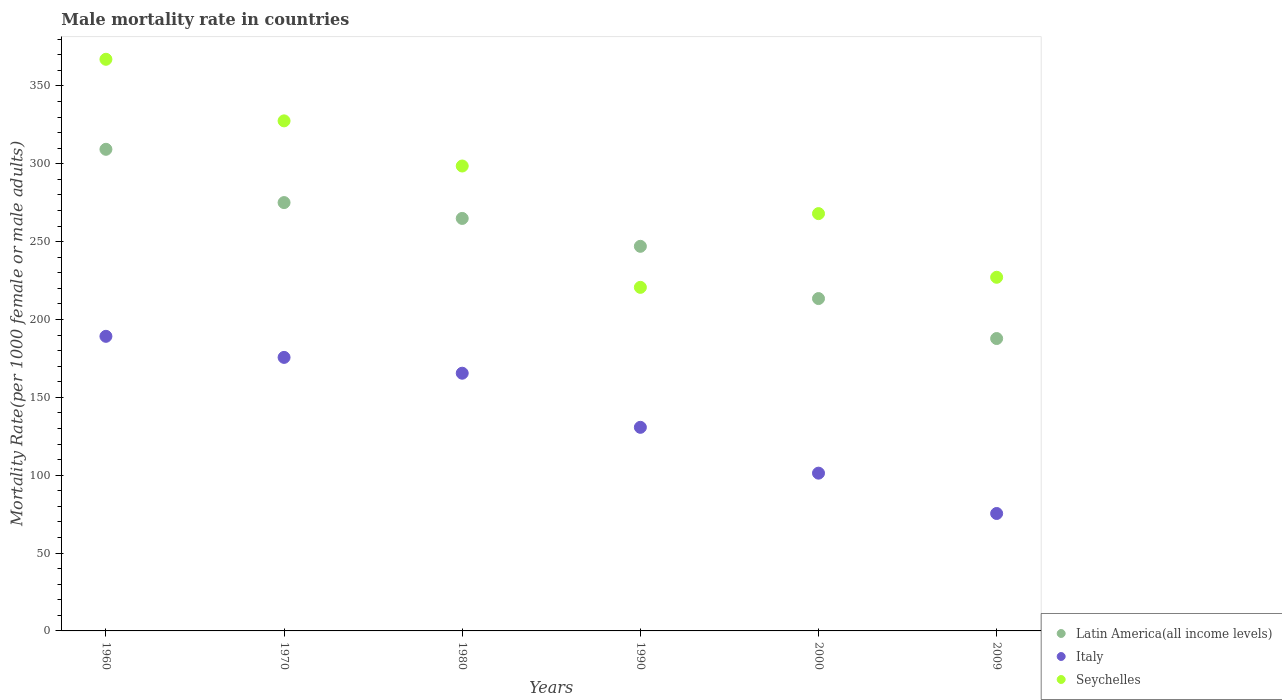How many different coloured dotlines are there?
Provide a succinct answer. 3. What is the male mortality rate in Italy in 1980?
Offer a very short reply. 165.5. Across all years, what is the maximum male mortality rate in Latin America(all income levels)?
Your response must be concise. 309.3. Across all years, what is the minimum male mortality rate in Latin America(all income levels)?
Ensure brevity in your answer.  187.78. What is the total male mortality rate in Seychelles in the graph?
Keep it short and to the point. 1709.01. What is the difference between the male mortality rate in Latin America(all income levels) in 1980 and that in 1990?
Offer a terse response. 17.91. What is the difference between the male mortality rate in Seychelles in 1960 and the male mortality rate in Latin America(all income levels) in 2000?
Your answer should be very brief. 153.67. What is the average male mortality rate in Latin America(all income levels) per year?
Ensure brevity in your answer.  249.58. In the year 1960, what is the difference between the male mortality rate in Latin America(all income levels) and male mortality rate in Italy?
Your answer should be compact. 120.1. What is the ratio of the male mortality rate in Latin America(all income levels) in 1960 to that in 2000?
Provide a succinct answer. 1.45. Is the difference between the male mortality rate in Latin America(all income levels) in 1980 and 2000 greater than the difference between the male mortality rate in Italy in 1980 and 2000?
Your answer should be compact. No. What is the difference between the highest and the second highest male mortality rate in Italy?
Offer a very short reply. 13.53. What is the difference between the highest and the lowest male mortality rate in Seychelles?
Provide a short and direct response. 146.47. Is the male mortality rate in Italy strictly less than the male mortality rate in Latin America(all income levels) over the years?
Keep it short and to the point. Yes. How many dotlines are there?
Make the answer very short. 3. How many years are there in the graph?
Your answer should be very brief. 6. Are the values on the major ticks of Y-axis written in scientific E-notation?
Make the answer very short. No. Does the graph contain grids?
Offer a terse response. No. Where does the legend appear in the graph?
Offer a terse response. Bottom right. How many legend labels are there?
Ensure brevity in your answer.  3. How are the legend labels stacked?
Offer a terse response. Vertical. What is the title of the graph?
Provide a short and direct response. Male mortality rate in countries. What is the label or title of the Y-axis?
Your response must be concise. Mortality Rate(per 1000 female or male adults). What is the Mortality Rate(per 1000 female or male adults) in Latin America(all income levels) in 1960?
Offer a very short reply. 309.3. What is the Mortality Rate(per 1000 female or male adults) of Italy in 1960?
Offer a very short reply. 189.2. What is the Mortality Rate(per 1000 female or male adults) of Seychelles in 1960?
Your response must be concise. 367.11. What is the Mortality Rate(per 1000 female or male adults) in Latin America(all income levels) in 1970?
Offer a terse response. 275.08. What is the Mortality Rate(per 1000 female or male adults) of Italy in 1970?
Provide a short and direct response. 175.66. What is the Mortality Rate(per 1000 female or male adults) of Seychelles in 1970?
Offer a terse response. 327.56. What is the Mortality Rate(per 1000 female or male adults) in Latin America(all income levels) in 1980?
Your response must be concise. 264.91. What is the Mortality Rate(per 1000 female or male adults) of Italy in 1980?
Offer a very short reply. 165.5. What is the Mortality Rate(per 1000 female or male adults) of Seychelles in 1980?
Give a very brief answer. 298.57. What is the Mortality Rate(per 1000 female or male adults) of Latin America(all income levels) in 1990?
Offer a terse response. 247. What is the Mortality Rate(per 1000 female or male adults) in Italy in 1990?
Keep it short and to the point. 130.75. What is the Mortality Rate(per 1000 female or male adults) in Seychelles in 1990?
Give a very brief answer. 220.65. What is the Mortality Rate(per 1000 female or male adults) in Latin America(all income levels) in 2000?
Make the answer very short. 213.44. What is the Mortality Rate(per 1000 female or male adults) in Italy in 2000?
Give a very brief answer. 101.32. What is the Mortality Rate(per 1000 female or male adults) of Seychelles in 2000?
Offer a very short reply. 268. What is the Mortality Rate(per 1000 female or male adults) in Latin America(all income levels) in 2009?
Provide a succinct answer. 187.78. What is the Mortality Rate(per 1000 female or male adults) of Italy in 2009?
Ensure brevity in your answer.  75.42. What is the Mortality Rate(per 1000 female or male adults) in Seychelles in 2009?
Your answer should be very brief. 227.12. Across all years, what is the maximum Mortality Rate(per 1000 female or male adults) in Latin America(all income levels)?
Make the answer very short. 309.3. Across all years, what is the maximum Mortality Rate(per 1000 female or male adults) of Italy?
Your answer should be compact. 189.2. Across all years, what is the maximum Mortality Rate(per 1000 female or male adults) of Seychelles?
Provide a succinct answer. 367.11. Across all years, what is the minimum Mortality Rate(per 1000 female or male adults) of Latin America(all income levels)?
Provide a succinct answer. 187.78. Across all years, what is the minimum Mortality Rate(per 1000 female or male adults) of Italy?
Offer a terse response. 75.42. Across all years, what is the minimum Mortality Rate(per 1000 female or male adults) of Seychelles?
Your answer should be very brief. 220.65. What is the total Mortality Rate(per 1000 female or male adults) in Latin America(all income levels) in the graph?
Provide a short and direct response. 1497.51. What is the total Mortality Rate(per 1000 female or male adults) in Italy in the graph?
Keep it short and to the point. 837.85. What is the total Mortality Rate(per 1000 female or male adults) in Seychelles in the graph?
Give a very brief answer. 1709.01. What is the difference between the Mortality Rate(per 1000 female or male adults) of Latin America(all income levels) in 1960 and that in 1970?
Keep it short and to the point. 34.22. What is the difference between the Mortality Rate(per 1000 female or male adults) in Italy in 1960 and that in 1970?
Provide a short and direct response. 13.53. What is the difference between the Mortality Rate(per 1000 female or male adults) of Seychelles in 1960 and that in 1970?
Make the answer very short. 39.55. What is the difference between the Mortality Rate(per 1000 female or male adults) in Latin America(all income levels) in 1960 and that in 1980?
Keep it short and to the point. 44.39. What is the difference between the Mortality Rate(per 1000 female or male adults) of Italy in 1960 and that in 1980?
Keep it short and to the point. 23.7. What is the difference between the Mortality Rate(per 1000 female or male adults) of Seychelles in 1960 and that in 1980?
Provide a short and direct response. 68.54. What is the difference between the Mortality Rate(per 1000 female or male adults) in Latin America(all income levels) in 1960 and that in 1990?
Your answer should be very brief. 62.3. What is the difference between the Mortality Rate(per 1000 female or male adults) of Italy in 1960 and that in 1990?
Keep it short and to the point. 58.44. What is the difference between the Mortality Rate(per 1000 female or male adults) of Seychelles in 1960 and that in 1990?
Give a very brief answer. 146.47. What is the difference between the Mortality Rate(per 1000 female or male adults) of Latin America(all income levels) in 1960 and that in 2000?
Ensure brevity in your answer.  95.86. What is the difference between the Mortality Rate(per 1000 female or male adults) of Italy in 1960 and that in 2000?
Ensure brevity in your answer.  87.88. What is the difference between the Mortality Rate(per 1000 female or male adults) in Seychelles in 1960 and that in 2000?
Offer a terse response. 99.11. What is the difference between the Mortality Rate(per 1000 female or male adults) of Latin America(all income levels) in 1960 and that in 2009?
Ensure brevity in your answer.  121.53. What is the difference between the Mortality Rate(per 1000 female or male adults) in Italy in 1960 and that in 2009?
Your response must be concise. 113.78. What is the difference between the Mortality Rate(per 1000 female or male adults) in Seychelles in 1960 and that in 2009?
Ensure brevity in your answer.  139.99. What is the difference between the Mortality Rate(per 1000 female or male adults) of Latin America(all income levels) in 1970 and that in 1980?
Make the answer very short. 10.17. What is the difference between the Mortality Rate(per 1000 female or male adults) in Italy in 1970 and that in 1980?
Your answer should be very brief. 10.16. What is the difference between the Mortality Rate(per 1000 female or male adults) in Seychelles in 1970 and that in 1980?
Your response must be concise. 28.99. What is the difference between the Mortality Rate(per 1000 female or male adults) in Latin America(all income levels) in 1970 and that in 1990?
Keep it short and to the point. 28.09. What is the difference between the Mortality Rate(per 1000 female or male adults) in Italy in 1970 and that in 1990?
Your response must be concise. 44.91. What is the difference between the Mortality Rate(per 1000 female or male adults) of Seychelles in 1970 and that in 1990?
Your answer should be very brief. 106.92. What is the difference between the Mortality Rate(per 1000 female or male adults) of Latin America(all income levels) in 1970 and that in 2000?
Offer a terse response. 61.64. What is the difference between the Mortality Rate(per 1000 female or male adults) in Italy in 1970 and that in 2000?
Provide a short and direct response. 74.34. What is the difference between the Mortality Rate(per 1000 female or male adults) of Seychelles in 1970 and that in 2000?
Keep it short and to the point. 59.56. What is the difference between the Mortality Rate(per 1000 female or male adults) in Latin America(all income levels) in 1970 and that in 2009?
Offer a very short reply. 87.31. What is the difference between the Mortality Rate(per 1000 female or male adults) of Italy in 1970 and that in 2009?
Your answer should be very brief. 100.24. What is the difference between the Mortality Rate(per 1000 female or male adults) of Seychelles in 1970 and that in 2009?
Your answer should be compact. 100.44. What is the difference between the Mortality Rate(per 1000 female or male adults) of Latin America(all income levels) in 1980 and that in 1990?
Make the answer very short. 17.91. What is the difference between the Mortality Rate(per 1000 female or male adults) of Italy in 1980 and that in 1990?
Keep it short and to the point. 34.74. What is the difference between the Mortality Rate(per 1000 female or male adults) in Seychelles in 1980 and that in 1990?
Your response must be concise. 77.93. What is the difference between the Mortality Rate(per 1000 female or male adults) of Latin America(all income levels) in 1980 and that in 2000?
Your response must be concise. 51.47. What is the difference between the Mortality Rate(per 1000 female or male adults) of Italy in 1980 and that in 2000?
Make the answer very short. 64.18. What is the difference between the Mortality Rate(per 1000 female or male adults) in Seychelles in 1980 and that in 2000?
Provide a short and direct response. 30.57. What is the difference between the Mortality Rate(per 1000 female or male adults) of Latin America(all income levels) in 1980 and that in 2009?
Give a very brief answer. 77.13. What is the difference between the Mortality Rate(per 1000 female or male adults) in Italy in 1980 and that in 2009?
Your answer should be compact. 90.08. What is the difference between the Mortality Rate(per 1000 female or male adults) in Seychelles in 1980 and that in 2009?
Your answer should be very brief. 71.46. What is the difference between the Mortality Rate(per 1000 female or male adults) in Latin America(all income levels) in 1990 and that in 2000?
Ensure brevity in your answer.  33.55. What is the difference between the Mortality Rate(per 1000 female or male adults) in Italy in 1990 and that in 2000?
Provide a short and direct response. 29.43. What is the difference between the Mortality Rate(per 1000 female or male adults) of Seychelles in 1990 and that in 2000?
Offer a very short reply. -47.35. What is the difference between the Mortality Rate(per 1000 female or male adults) in Latin America(all income levels) in 1990 and that in 2009?
Give a very brief answer. 59.22. What is the difference between the Mortality Rate(per 1000 female or male adults) of Italy in 1990 and that in 2009?
Your answer should be compact. 55.34. What is the difference between the Mortality Rate(per 1000 female or male adults) in Seychelles in 1990 and that in 2009?
Your response must be concise. -6.47. What is the difference between the Mortality Rate(per 1000 female or male adults) in Latin America(all income levels) in 2000 and that in 2009?
Ensure brevity in your answer.  25.67. What is the difference between the Mortality Rate(per 1000 female or male adults) in Italy in 2000 and that in 2009?
Give a very brief answer. 25.9. What is the difference between the Mortality Rate(per 1000 female or male adults) of Seychelles in 2000 and that in 2009?
Offer a terse response. 40.88. What is the difference between the Mortality Rate(per 1000 female or male adults) of Latin America(all income levels) in 1960 and the Mortality Rate(per 1000 female or male adults) of Italy in 1970?
Ensure brevity in your answer.  133.64. What is the difference between the Mortality Rate(per 1000 female or male adults) in Latin America(all income levels) in 1960 and the Mortality Rate(per 1000 female or male adults) in Seychelles in 1970?
Ensure brevity in your answer.  -18.26. What is the difference between the Mortality Rate(per 1000 female or male adults) of Italy in 1960 and the Mortality Rate(per 1000 female or male adults) of Seychelles in 1970?
Your answer should be very brief. -138.36. What is the difference between the Mortality Rate(per 1000 female or male adults) in Latin America(all income levels) in 1960 and the Mortality Rate(per 1000 female or male adults) in Italy in 1980?
Your answer should be compact. 143.8. What is the difference between the Mortality Rate(per 1000 female or male adults) of Latin America(all income levels) in 1960 and the Mortality Rate(per 1000 female or male adults) of Seychelles in 1980?
Your answer should be very brief. 10.73. What is the difference between the Mortality Rate(per 1000 female or male adults) of Italy in 1960 and the Mortality Rate(per 1000 female or male adults) of Seychelles in 1980?
Offer a very short reply. -109.38. What is the difference between the Mortality Rate(per 1000 female or male adults) in Latin America(all income levels) in 1960 and the Mortality Rate(per 1000 female or male adults) in Italy in 1990?
Provide a succinct answer. 178.55. What is the difference between the Mortality Rate(per 1000 female or male adults) in Latin America(all income levels) in 1960 and the Mortality Rate(per 1000 female or male adults) in Seychelles in 1990?
Offer a very short reply. 88.65. What is the difference between the Mortality Rate(per 1000 female or male adults) of Italy in 1960 and the Mortality Rate(per 1000 female or male adults) of Seychelles in 1990?
Make the answer very short. -31.45. What is the difference between the Mortality Rate(per 1000 female or male adults) in Latin America(all income levels) in 1960 and the Mortality Rate(per 1000 female or male adults) in Italy in 2000?
Ensure brevity in your answer.  207.98. What is the difference between the Mortality Rate(per 1000 female or male adults) in Latin America(all income levels) in 1960 and the Mortality Rate(per 1000 female or male adults) in Seychelles in 2000?
Provide a succinct answer. 41.3. What is the difference between the Mortality Rate(per 1000 female or male adults) of Italy in 1960 and the Mortality Rate(per 1000 female or male adults) of Seychelles in 2000?
Provide a succinct answer. -78.8. What is the difference between the Mortality Rate(per 1000 female or male adults) of Latin America(all income levels) in 1960 and the Mortality Rate(per 1000 female or male adults) of Italy in 2009?
Provide a succinct answer. 233.88. What is the difference between the Mortality Rate(per 1000 female or male adults) of Latin America(all income levels) in 1960 and the Mortality Rate(per 1000 female or male adults) of Seychelles in 2009?
Make the answer very short. 82.18. What is the difference between the Mortality Rate(per 1000 female or male adults) of Italy in 1960 and the Mortality Rate(per 1000 female or male adults) of Seychelles in 2009?
Ensure brevity in your answer.  -37.92. What is the difference between the Mortality Rate(per 1000 female or male adults) in Latin America(all income levels) in 1970 and the Mortality Rate(per 1000 female or male adults) in Italy in 1980?
Ensure brevity in your answer.  109.58. What is the difference between the Mortality Rate(per 1000 female or male adults) of Latin America(all income levels) in 1970 and the Mortality Rate(per 1000 female or male adults) of Seychelles in 1980?
Offer a terse response. -23.49. What is the difference between the Mortality Rate(per 1000 female or male adults) of Italy in 1970 and the Mortality Rate(per 1000 female or male adults) of Seychelles in 1980?
Offer a terse response. -122.91. What is the difference between the Mortality Rate(per 1000 female or male adults) in Latin America(all income levels) in 1970 and the Mortality Rate(per 1000 female or male adults) in Italy in 1990?
Give a very brief answer. 144.33. What is the difference between the Mortality Rate(per 1000 female or male adults) of Latin America(all income levels) in 1970 and the Mortality Rate(per 1000 female or male adults) of Seychelles in 1990?
Give a very brief answer. 54.44. What is the difference between the Mortality Rate(per 1000 female or male adults) in Italy in 1970 and the Mortality Rate(per 1000 female or male adults) in Seychelles in 1990?
Provide a succinct answer. -44.98. What is the difference between the Mortality Rate(per 1000 female or male adults) in Latin America(all income levels) in 1970 and the Mortality Rate(per 1000 female or male adults) in Italy in 2000?
Make the answer very short. 173.76. What is the difference between the Mortality Rate(per 1000 female or male adults) in Latin America(all income levels) in 1970 and the Mortality Rate(per 1000 female or male adults) in Seychelles in 2000?
Give a very brief answer. 7.08. What is the difference between the Mortality Rate(per 1000 female or male adults) of Italy in 1970 and the Mortality Rate(per 1000 female or male adults) of Seychelles in 2000?
Keep it short and to the point. -92.34. What is the difference between the Mortality Rate(per 1000 female or male adults) of Latin America(all income levels) in 1970 and the Mortality Rate(per 1000 female or male adults) of Italy in 2009?
Provide a succinct answer. 199.66. What is the difference between the Mortality Rate(per 1000 female or male adults) in Latin America(all income levels) in 1970 and the Mortality Rate(per 1000 female or male adults) in Seychelles in 2009?
Offer a very short reply. 47.97. What is the difference between the Mortality Rate(per 1000 female or male adults) in Italy in 1970 and the Mortality Rate(per 1000 female or male adults) in Seychelles in 2009?
Offer a very short reply. -51.45. What is the difference between the Mortality Rate(per 1000 female or male adults) of Latin America(all income levels) in 1980 and the Mortality Rate(per 1000 female or male adults) of Italy in 1990?
Make the answer very short. 134.16. What is the difference between the Mortality Rate(per 1000 female or male adults) in Latin America(all income levels) in 1980 and the Mortality Rate(per 1000 female or male adults) in Seychelles in 1990?
Give a very brief answer. 44.26. What is the difference between the Mortality Rate(per 1000 female or male adults) of Italy in 1980 and the Mortality Rate(per 1000 female or male adults) of Seychelles in 1990?
Keep it short and to the point. -55.15. What is the difference between the Mortality Rate(per 1000 female or male adults) in Latin America(all income levels) in 1980 and the Mortality Rate(per 1000 female or male adults) in Italy in 2000?
Your response must be concise. 163.59. What is the difference between the Mortality Rate(per 1000 female or male adults) of Latin America(all income levels) in 1980 and the Mortality Rate(per 1000 female or male adults) of Seychelles in 2000?
Provide a succinct answer. -3.09. What is the difference between the Mortality Rate(per 1000 female or male adults) in Italy in 1980 and the Mortality Rate(per 1000 female or male adults) in Seychelles in 2000?
Offer a terse response. -102.5. What is the difference between the Mortality Rate(per 1000 female or male adults) in Latin America(all income levels) in 1980 and the Mortality Rate(per 1000 female or male adults) in Italy in 2009?
Your answer should be very brief. 189.49. What is the difference between the Mortality Rate(per 1000 female or male adults) in Latin America(all income levels) in 1980 and the Mortality Rate(per 1000 female or male adults) in Seychelles in 2009?
Provide a short and direct response. 37.79. What is the difference between the Mortality Rate(per 1000 female or male adults) in Italy in 1980 and the Mortality Rate(per 1000 female or male adults) in Seychelles in 2009?
Offer a very short reply. -61.62. What is the difference between the Mortality Rate(per 1000 female or male adults) in Latin America(all income levels) in 1990 and the Mortality Rate(per 1000 female or male adults) in Italy in 2000?
Offer a very short reply. 145.68. What is the difference between the Mortality Rate(per 1000 female or male adults) of Latin America(all income levels) in 1990 and the Mortality Rate(per 1000 female or male adults) of Seychelles in 2000?
Ensure brevity in your answer.  -21. What is the difference between the Mortality Rate(per 1000 female or male adults) of Italy in 1990 and the Mortality Rate(per 1000 female or male adults) of Seychelles in 2000?
Your response must be concise. -137.25. What is the difference between the Mortality Rate(per 1000 female or male adults) of Latin America(all income levels) in 1990 and the Mortality Rate(per 1000 female or male adults) of Italy in 2009?
Keep it short and to the point. 171.58. What is the difference between the Mortality Rate(per 1000 female or male adults) in Latin America(all income levels) in 1990 and the Mortality Rate(per 1000 female or male adults) in Seychelles in 2009?
Offer a terse response. 19.88. What is the difference between the Mortality Rate(per 1000 female or male adults) of Italy in 1990 and the Mortality Rate(per 1000 female or male adults) of Seychelles in 2009?
Your answer should be very brief. -96.36. What is the difference between the Mortality Rate(per 1000 female or male adults) of Latin America(all income levels) in 2000 and the Mortality Rate(per 1000 female or male adults) of Italy in 2009?
Offer a very short reply. 138.02. What is the difference between the Mortality Rate(per 1000 female or male adults) of Latin America(all income levels) in 2000 and the Mortality Rate(per 1000 female or male adults) of Seychelles in 2009?
Your response must be concise. -13.67. What is the difference between the Mortality Rate(per 1000 female or male adults) of Italy in 2000 and the Mortality Rate(per 1000 female or male adults) of Seychelles in 2009?
Your response must be concise. -125.8. What is the average Mortality Rate(per 1000 female or male adults) of Latin America(all income levels) per year?
Provide a succinct answer. 249.58. What is the average Mortality Rate(per 1000 female or male adults) in Italy per year?
Offer a terse response. 139.64. What is the average Mortality Rate(per 1000 female or male adults) in Seychelles per year?
Provide a short and direct response. 284.84. In the year 1960, what is the difference between the Mortality Rate(per 1000 female or male adults) in Latin America(all income levels) and Mortality Rate(per 1000 female or male adults) in Italy?
Make the answer very short. 120.1. In the year 1960, what is the difference between the Mortality Rate(per 1000 female or male adults) of Latin America(all income levels) and Mortality Rate(per 1000 female or male adults) of Seychelles?
Your answer should be compact. -57.81. In the year 1960, what is the difference between the Mortality Rate(per 1000 female or male adults) in Italy and Mortality Rate(per 1000 female or male adults) in Seychelles?
Ensure brevity in your answer.  -177.91. In the year 1970, what is the difference between the Mortality Rate(per 1000 female or male adults) in Latin America(all income levels) and Mortality Rate(per 1000 female or male adults) in Italy?
Give a very brief answer. 99.42. In the year 1970, what is the difference between the Mortality Rate(per 1000 female or male adults) of Latin America(all income levels) and Mortality Rate(per 1000 female or male adults) of Seychelles?
Provide a succinct answer. -52.48. In the year 1970, what is the difference between the Mortality Rate(per 1000 female or male adults) in Italy and Mortality Rate(per 1000 female or male adults) in Seychelles?
Provide a succinct answer. -151.9. In the year 1980, what is the difference between the Mortality Rate(per 1000 female or male adults) in Latin America(all income levels) and Mortality Rate(per 1000 female or male adults) in Italy?
Your response must be concise. 99.41. In the year 1980, what is the difference between the Mortality Rate(per 1000 female or male adults) of Latin America(all income levels) and Mortality Rate(per 1000 female or male adults) of Seychelles?
Make the answer very short. -33.67. In the year 1980, what is the difference between the Mortality Rate(per 1000 female or male adults) in Italy and Mortality Rate(per 1000 female or male adults) in Seychelles?
Make the answer very short. -133.08. In the year 1990, what is the difference between the Mortality Rate(per 1000 female or male adults) of Latin America(all income levels) and Mortality Rate(per 1000 female or male adults) of Italy?
Ensure brevity in your answer.  116.24. In the year 1990, what is the difference between the Mortality Rate(per 1000 female or male adults) in Latin America(all income levels) and Mortality Rate(per 1000 female or male adults) in Seychelles?
Keep it short and to the point. 26.35. In the year 1990, what is the difference between the Mortality Rate(per 1000 female or male adults) in Italy and Mortality Rate(per 1000 female or male adults) in Seychelles?
Your response must be concise. -89.89. In the year 2000, what is the difference between the Mortality Rate(per 1000 female or male adults) of Latin America(all income levels) and Mortality Rate(per 1000 female or male adults) of Italy?
Give a very brief answer. 112.12. In the year 2000, what is the difference between the Mortality Rate(per 1000 female or male adults) of Latin America(all income levels) and Mortality Rate(per 1000 female or male adults) of Seychelles?
Your response must be concise. -54.56. In the year 2000, what is the difference between the Mortality Rate(per 1000 female or male adults) in Italy and Mortality Rate(per 1000 female or male adults) in Seychelles?
Your answer should be compact. -166.68. In the year 2009, what is the difference between the Mortality Rate(per 1000 female or male adults) of Latin America(all income levels) and Mortality Rate(per 1000 female or male adults) of Italy?
Provide a succinct answer. 112.36. In the year 2009, what is the difference between the Mortality Rate(per 1000 female or male adults) of Latin America(all income levels) and Mortality Rate(per 1000 female or male adults) of Seychelles?
Offer a very short reply. -39.34. In the year 2009, what is the difference between the Mortality Rate(per 1000 female or male adults) of Italy and Mortality Rate(per 1000 female or male adults) of Seychelles?
Your answer should be very brief. -151.7. What is the ratio of the Mortality Rate(per 1000 female or male adults) of Latin America(all income levels) in 1960 to that in 1970?
Offer a very short reply. 1.12. What is the ratio of the Mortality Rate(per 1000 female or male adults) of Italy in 1960 to that in 1970?
Your response must be concise. 1.08. What is the ratio of the Mortality Rate(per 1000 female or male adults) in Seychelles in 1960 to that in 1970?
Your answer should be very brief. 1.12. What is the ratio of the Mortality Rate(per 1000 female or male adults) of Latin America(all income levels) in 1960 to that in 1980?
Your answer should be compact. 1.17. What is the ratio of the Mortality Rate(per 1000 female or male adults) of Italy in 1960 to that in 1980?
Keep it short and to the point. 1.14. What is the ratio of the Mortality Rate(per 1000 female or male adults) in Seychelles in 1960 to that in 1980?
Provide a short and direct response. 1.23. What is the ratio of the Mortality Rate(per 1000 female or male adults) in Latin America(all income levels) in 1960 to that in 1990?
Give a very brief answer. 1.25. What is the ratio of the Mortality Rate(per 1000 female or male adults) of Italy in 1960 to that in 1990?
Keep it short and to the point. 1.45. What is the ratio of the Mortality Rate(per 1000 female or male adults) of Seychelles in 1960 to that in 1990?
Your response must be concise. 1.66. What is the ratio of the Mortality Rate(per 1000 female or male adults) in Latin America(all income levels) in 1960 to that in 2000?
Ensure brevity in your answer.  1.45. What is the ratio of the Mortality Rate(per 1000 female or male adults) of Italy in 1960 to that in 2000?
Make the answer very short. 1.87. What is the ratio of the Mortality Rate(per 1000 female or male adults) in Seychelles in 1960 to that in 2000?
Offer a very short reply. 1.37. What is the ratio of the Mortality Rate(per 1000 female or male adults) of Latin America(all income levels) in 1960 to that in 2009?
Provide a succinct answer. 1.65. What is the ratio of the Mortality Rate(per 1000 female or male adults) in Italy in 1960 to that in 2009?
Ensure brevity in your answer.  2.51. What is the ratio of the Mortality Rate(per 1000 female or male adults) of Seychelles in 1960 to that in 2009?
Your answer should be compact. 1.62. What is the ratio of the Mortality Rate(per 1000 female or male adults) in Latin America(all income levels) in 1970 to that in 1980?
Offer a very short reply. 1.04. What is the ratio of the Mortality Rate(per 1000 female or male adults) of Italy in 1970 to that in 1980?
Give a very brief answer. 1.06. What is the ratio of the Mortality Rate(per 1000 female or male adults) of Seychelles in 1970 to that in 1980?
Your answer should be very brief. 1.1. What is the ratio of the Mortality Rate(per 1000 female or male adults) of Latin America(all income levels) in 1970 to that in 1990?
Give a very brief answer. 1.11. What is the ratio of the Mortality Rate(per 1000 female or male adults) in Italy in 1970 to that in 1990?
Your answer should be compact. 1.34. What is the ratio of the Mortality Rate(per 1000 female or male adults) in Seychelles in 1970 to that in 1990?
Provide a succinct answer. 1.48. What is the ratio of the Mortality Rate(per 1000 female or male adults) of Latin America(all income levels) in 1970 to that in 2000?
Offer a very short reply. 1.29. What is the ratio of the Mortality Rate(per 1000 female or male adults) in Italy in 1970 to that in 2000?
Keep it short and to the point. 1.73. What is the ratio of the Mortality Rate(per 1000 female or male adults) of Seychelles in 1970 to that in 2000?
Provide a succinct answer. 1.22. What is the ratio of the Mortality Rate(per 1000 female or male adults) of Latin America(all income levels) in 1970 to that in 2009?
Provide a succinct answer. 1.47. What is the ratio of the Mortality Rate(per 1000 female or male adults) in Italy in 1970 to that in 2009?
Provide a succinct answer. 2.33. What is the ratio of the Mortality Rate(per 1000 female or male adults) of Seychelles in 1970 to that in 2009?
Your answer should be compact. 1.44. What is the ratio of the Mortality Rate(per 1000 female or male adults) of Latin America(all income levels) in 1980 to that in 1990?
Provide a short and direct response. 1.07. What is the ratio of the Mortality Rate(per 1000 female or male adults) in Italy in 1980 to that in 1990?
Provide a short and direct response. 1.27. What is the ratio of the Mortality Rate(per 1000 female or male adults) in Seychelles in 1980 to that in 1990?
Offer a terse response. 1.35. What is the ratio of the Mortality Rate(per 1000 female or male adults) of Latin America(all income levels) in 1980 to that in 2000?
Offer a very short reply. 1.24. What is the ratio of the Mortality Rate(per 1000 female or male adults) in Italy in 1980 to that in 2000?
Give a very brief answer. 1.63. What is the ratio of the Mortality Rate(per 1000 female or male adults) of Seychelles in 1980 to that in 2000?
Your answer should be compact. 1.11. What is the ratio of the Mortality Rate(per 1000 female or male adults) of Latin America(all income levels) in 1980 to that in 2009?
Provide a short and direct response. 1.41. What is the ratio of the Mortality Rate(per 1000 female or male adults) of Italy in 1980 to that in 2009?
Your response must be concise. 2.19. What is the ratio of the Mortality Rate(per 1000 female or male adults) in Seychelles in 1980 to that in 2009?
Provide a succinct answer. 1.31. What is the ratio of the Mortality Rate(per 1000 female or male adults) in Latin America(all income levels) in 1990 to that in 2000?
Offer a terse response. 1.16. What is the ratio of the Mortality Rate(per 1000 female or male adults) of Italy in 1990 to that in 2000?
Ensure brevity in your answer.  1.29. What is the ratio of the Mortality Rate(per 1000 female or male adults) of Seychelles in 1990 to that in 2000?
Provide a succinct answer. 0.82. What is the ratio of the Mortality Rate(per 1000 female or male adults) in Latin America(all income levels) in 1990 to that in 2009?
Provide a short and direct response. 1.32. What is the ratio of the Mortality Rate(per 1000 female or male adults) of Italy in 1990 to that in 2009?
Provide a succinct answer. 1.73. What is the ratio of the Mortality Rate(per 1000 female or male adults) of Seychelles in 1990 to that in 2009?
Ensure brevity in your answer.  0.97. What is the ratio of the Mortality Rate(per 1000 female or male adults) in Latin America(all income levels) in 2000 to that in 2009?
Offer a very short reply. 1.14. What is the ratio of the Mortality Rate(per 1000 female or male adults) of Italy in 2000 to that in 2009?
Make the answer very short. 1.34. What is the ratio of the Mortality Rate(per 1000 female or male adults) of Seychelles in 2000 to that in 2009?
Offer a very short reply. 1.18. What is the difference between the highest and the second highest Mortality Rate(per 1000 female or male adults) of Latin America(all income levels)?
Your answer should be compact. 34.22. What is the difference between the highest and the second highest Mortality Rate(per 1000 female or male adults) of Italy?
Provide a succinct answer. 13.53. What is the difference between the highest and the second highest Mortality Rate(per 1000 female or male adults) in Seychelles?
Offer a terse response. 39.55. What is the difference between the highest and the lowest Mortality Rate(per 1000 female or male adults) of Latin America(all income levels)?
Offer a terse response. 121.53. What is the difference between the highest and the lowest Mortality Rate(per 1000 female or male adults) of Italy?
Your answer should be compact. 113.78. What is the difference between the highest and the lowest Mortality Rate(per 1000 female or male adults) of Seychelles?
Offer a terse response. 146.47. 